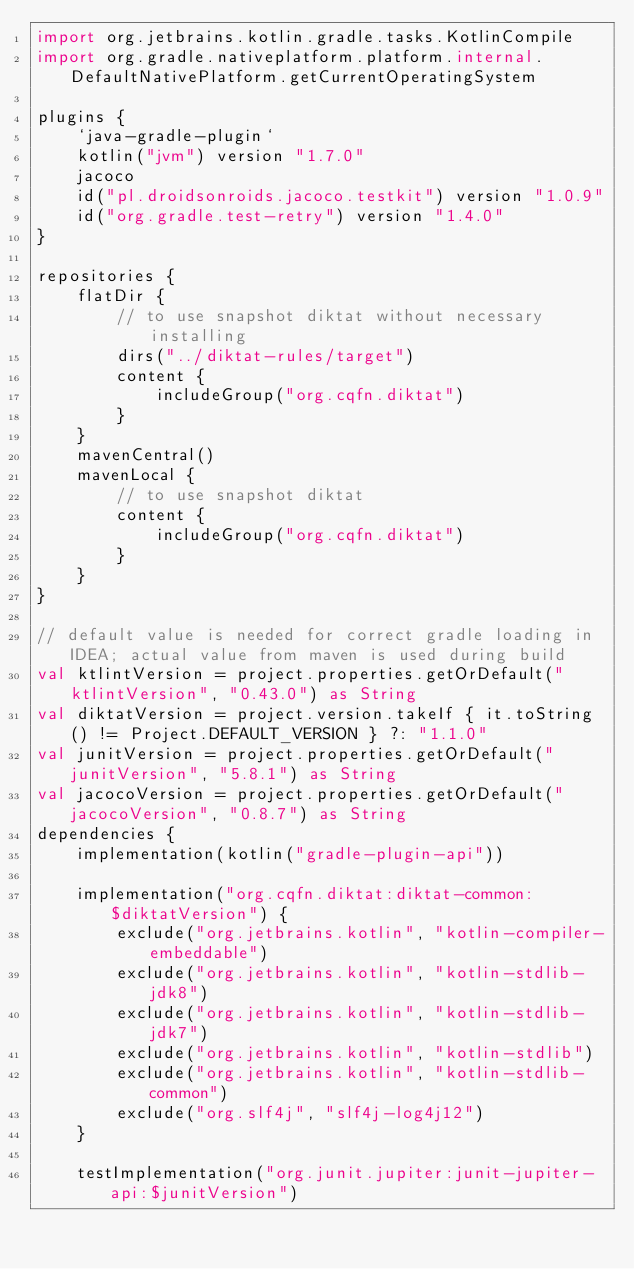Convert code to text. <code><loc_0><loc_0><loc_500><loc_500><_Kotlin_>import org.jetbrains.kotlin.gradle.tasks.KotlinCompile
import org.gradle.nativeplatform.platform.internal.DefaultNativePlatform.getCurrentOperatingSystem

plugins {
    `java-gradle-plugin`
    kotlin("jvm") version "1.7.0"
    jacoco
    id("pl.droidsonroids.jacoco.testkit") version "1.0.9"
    id("org.gradle.test-retry") version "1.4.0"
}

repositories {
    flatDir {
        // to use snapshot diktat without necessary installing
        dirs("../diktat-rules/target")
        content {
            includeGroup("org.cqfn.diktat")
        }
    }
    mavenCentral()
    mavenLocal {
        // to use snapshot diktat
        content {
            includeGroup("org.cqfn.diktat")
        }
    }
}

// default value is needed for correct gradle loading in IDEA; actual value from maven is used during build
val ktlintVersion = project.properties.getOrDefault("ktlintVersion", "0.43.0") as String
val diktatVersion = project.version.takeIf { it.toString() != Project.DEFAULT_VERSION } ?: "1.1.0"
val junitVersion = project.properties.getOrDefault("junitVersion", "5.8.1") as String
val jacocoVersion = project.properties.getOrDefault("jacocoVersion", "0.8.7") as String
dependencies {
    implementation(kotlin("gradle-plugin-api"))

    implementation("org.cqfn.diktat:diktat-common:$diktatVersion") {
        exclude("org.jetbrains.kotlin", "kotlin-compiler-embeddable")
        exclude("org.jetbrains.kotlin", "kotlin-stdlib-jdk8")
        exclude("org.jetbrains.kotlin", "kotlin-stdlib-jdk7")
        exclude("org.jetbrains.kotlin", "kotlin-stdlib")
        exclude("org.jetbrains.kotlin", "kotlin-stdlib-common")
        exclude("org.slf4j", "slf4j-log4j12")
    }

    testImplementation("org.junit.jupiter:junit-jupiter-api:$junitVersion")</code> 